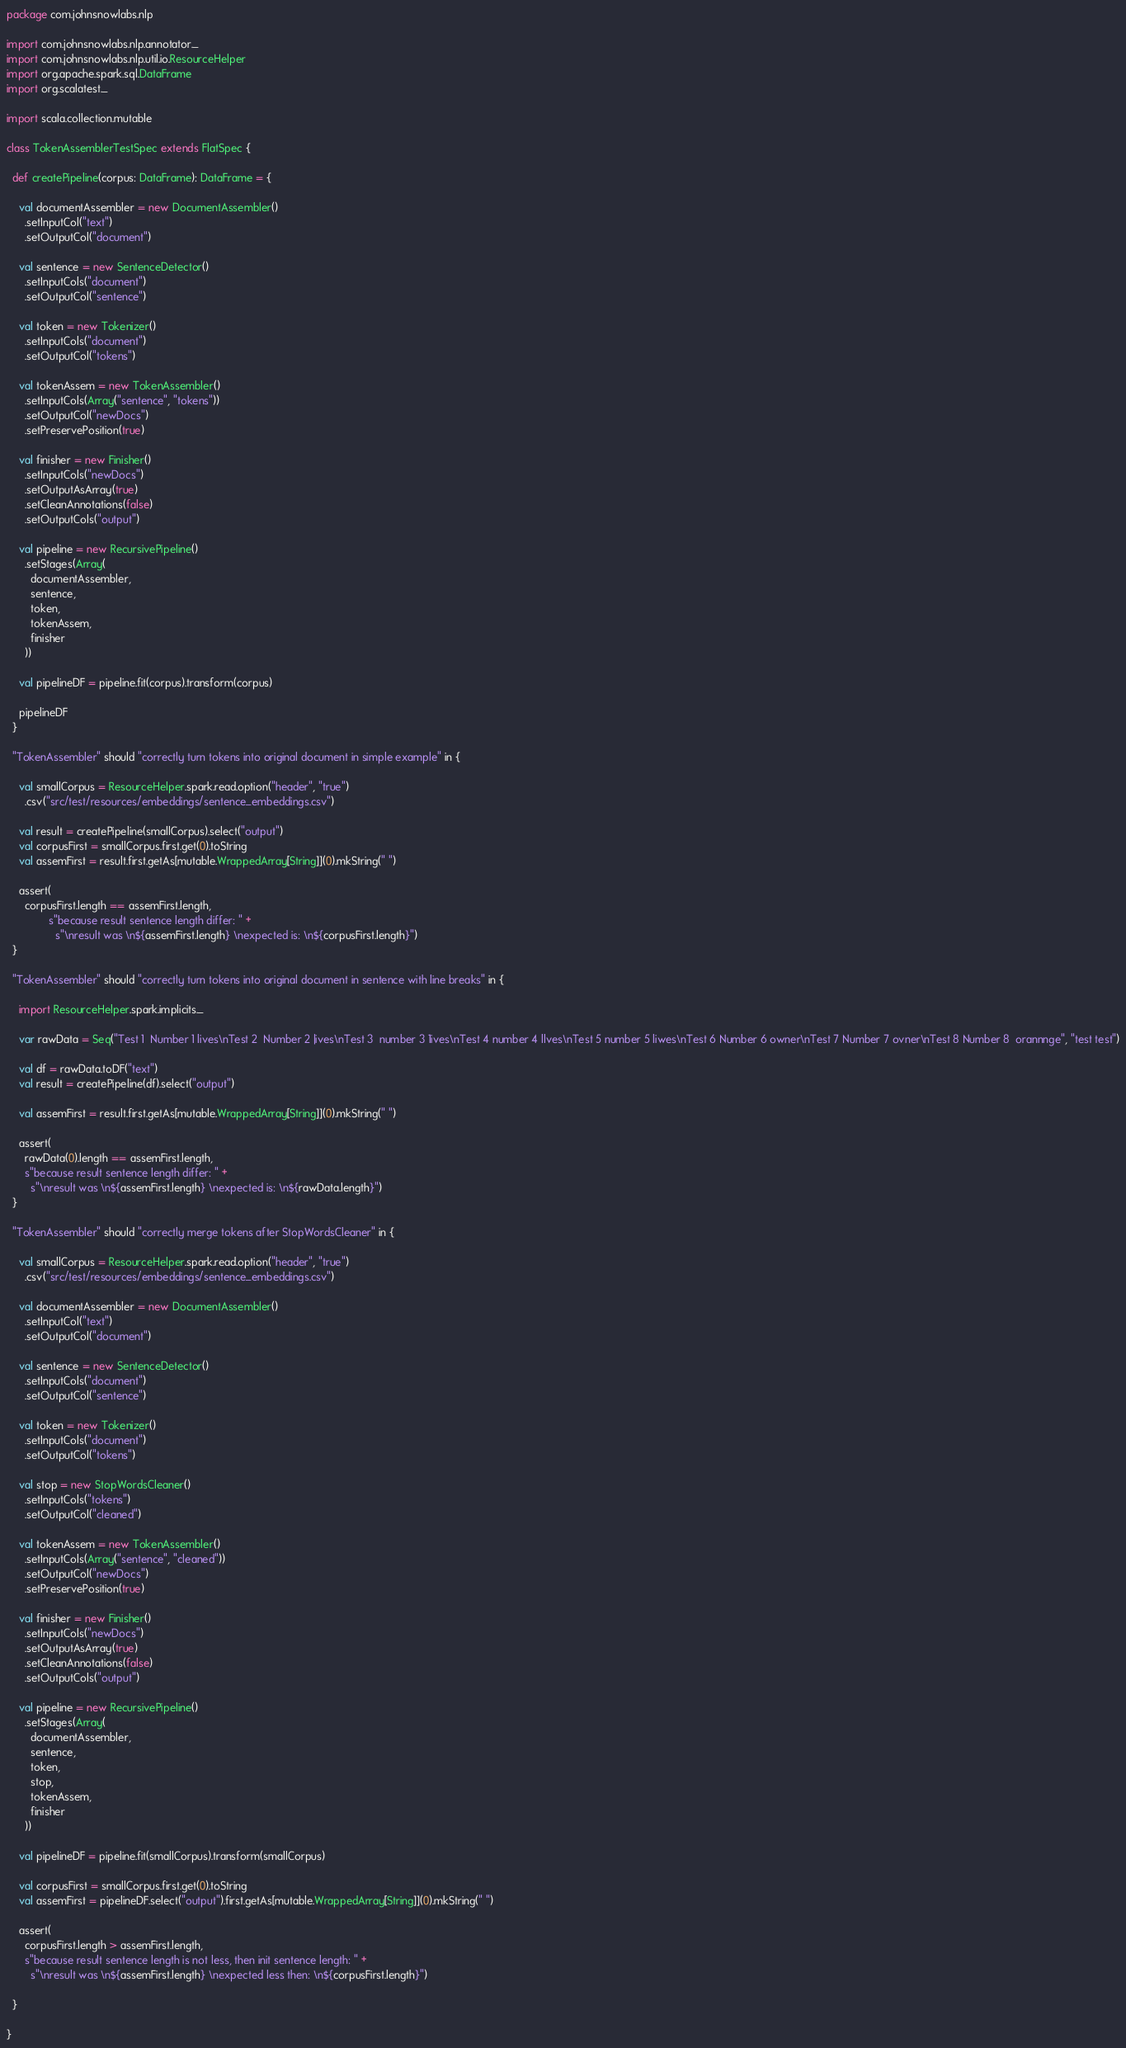<code> <loc_0><loc_0><loc_500><loc_500><_Scala_>package com.johnsnowlabs.nlp

import com.johnsnowlabs.nlp.annotator._
import com.johnsnowlabs.nlp.util.io.ResourceHelper
import org.apache.spark.sql.DataFrame
import org.scalatest._

import scala.collection.mutable

class TokenAssemblerTestSpec extends FlatSpec {

  def createPipeline(corpus: DataFrame): DataFrame = {

    val documentAssembler = new DocumentAssembler()
      .setInputCol("text")
      .setOutputCol("document")

    val sentence = new SentenceDetector()
      .setInputCols("document")
      .setOutputCol("sentence")

    val token = new Tokenizer()
      .setInputCols("document")
      .setOutputCol("tokens")

    val tokenAssem = new TokenAssembler()
      .setInputCols(Array("sentence", "tokens"))
      .setOutputCol("newDocs")
      .setPreservePosition(true)

    val finisher = new Finisher()
      .setInputCols("newDocs")
      .setOutputAsArray(true)
      .setCleanAnnotations(false)
      .setOutputCols("output")

    val pipeline = new RecursivePipeline()
      .setStages(Array(
        documentAssembler,
        sentence,
        token,
        tokenAssem,
        finisher
      ))

    val pipelineDF = pipeline.fit(corpus).transform(corpus)

    pipelineDF
  }

  "TokenAssembler" should "correctly turn tokens into original document in simple example" in {

    val smallCorpus = ResourceHelper.spark.read.option("header", "true")
      .csv("src/test/resources/embeddings/sentence_embeddings.csv")

    val result = createPipeline(smallCorpus).select("output")
    val corpusFirst = smallCorpus.first.get(0).toString
    val assemFirst = result.first.getAs[mutable.WrappedArray[String]](0).mkString(" ")

    assert(
      corpusFirst.length == assemFirst.length,
              s"because result sentence length differ: " +
                s"\nresult was \n${assemFirst.length} \nexpected is: \n${corpusFirst.length}")
  }

  "TokenAssembler" should "correctly turn tokens into original document in sentence with line breaks" in {

    import ResourceHelper.spark.implicits._

    var rawData = Seq("Test 1  Number 1 lives\nTest 2  Number 2 |ives\nTest 3  number 3 1ives\nTest 4 number 4 llves\nTest 5 number 5 liwes\nTest 6 Number 6 owner\nTest 7 Number 7 ovner\nTest 8 Number 8  orannnge", "test test")

    val df = rawData.toDF("text")
    val result = createPipeline(df).select("output")

    val assemFirst = result.first.getAs[mutable.WrappedArray[String]](0).mkString(" ")

    assert(
      rawData(0).length == assemFirst.length,
      s"because result sentence length differ: " +
        s"\nresult was \n${assemFirst.length} \nexpected is: \n${rawData.length}")
  }

  "TokenAssembler" should "correctly merge tokens after StopWordsCleaner" in {

    val smallCorpus = ResourceHelper.spark.read.option("header", "true")
      .csv("src/test/resources/embeddings/sentence_embeddings.csv")

    val documentAssembler = new DocumentAssembler()
      .setInputCol("text")
      .setOutputCol("document")

    val sentence = new SentenceDetector()
      .setInputCols("document")
      .setOutputCol("sentence")

    val token = new Tokenizer()
      .setInputCols("document")
      .setOutputCol("tokens")

    val stop = new StopWordsCleaner()
      .setInputCols("tokens")
      .setOutputCol("cleaned")

    val tokenAssem = new TokenAssembler()
      .setInputCols(Array("sentence", "cleaned"))
      .setOutputCol("newDocs")
      .setPreservePosition(true)

    val finisher = new Finisher()
      .setInputCols("newDocs")
      .setOutputAsArray(true)
      .setCleanAnnotations(false)
      .setOutputCols("output")

    val pipeline = new RecursivePipeline()
      .setStages(Array(
        documentAssembler,
        sentence,
        token,
        stop,
        tokenAssem,
        finisher
      ))

    val pipelineDF = pipeline.fit(smallCorpus).transform(smallCorpus)

    val corpusFirst = smallCorpus.first.get(0).toString
    val assemFirst = pipelineDF.select("output").first.getAs[mutable.WrappedArray[String]](0).mkString(" ")

    assert(
      corpusFirst.length > assemFirst.length,
      s"because result sentence length is not less, then init sentence length: " +
        s"\nresult was \n${assemFirst.length} \nexpected less then: \n${corpusFirst.length}")

  }

}
</code> 